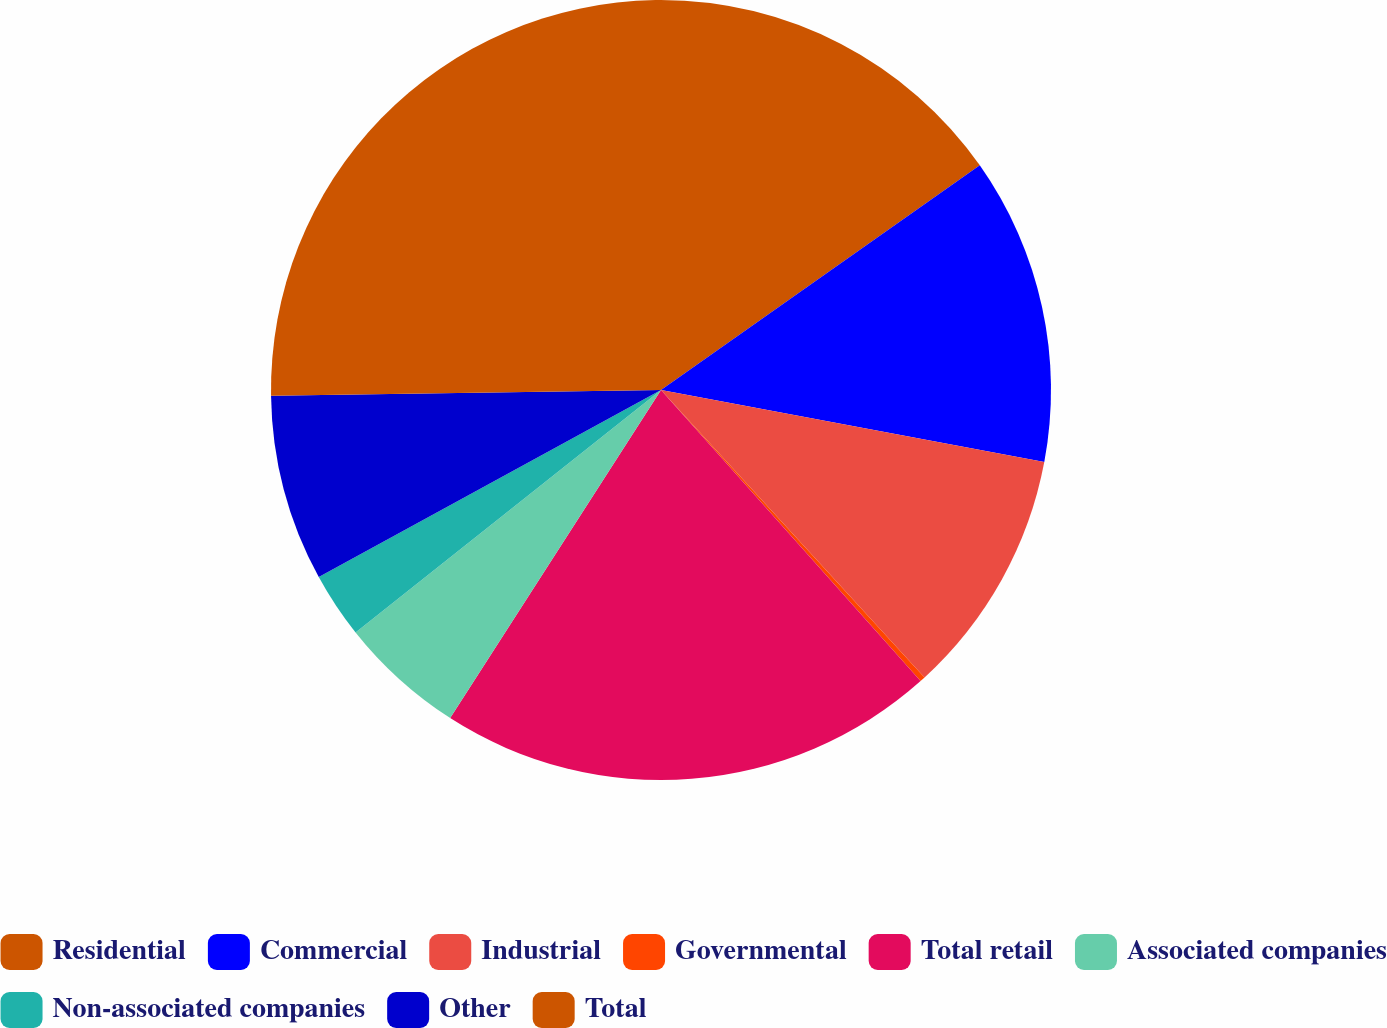Convert chart to OTSL. <chart><loc_0><loc_0><loc_500><loc_500><pie_chart><fcel>Residential<fcel>Commercial<fcel>Industrial<fcel>Governmental<fcel>Total retail<fcel>Associated companies<fcel>Non-associated companies<fcel>Other<fcel>Total<nl><fcel>15.23%<fcel>12.73%<fcel>10.23%<fcel>0.22%<fcel>20.68%<fcel>5.23%<fcel>2.72%<fcel>7.73%<fcel>25.23%<nl></chart> 